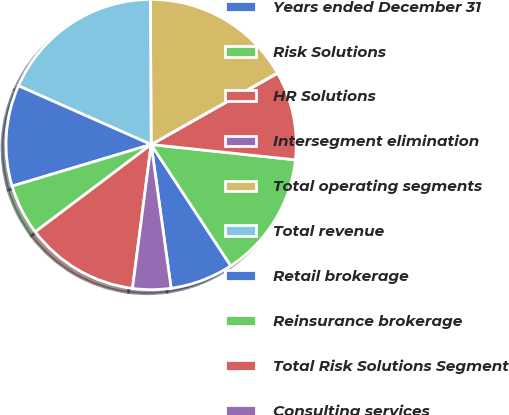<chart> <loc_0><loc_0><loc_500><loc_500><pie_chart><fcel>Years ended December 31<fcel>Risk Solutions<fcel>HR Solutions<fcel>Intersegment elimination<fcel>Total operating segments<fcel>Total revenue<fcel>Retail brokerage<fcel>Reinsurance brokerage<fcel>Total Risk Solutions Segment<fcel>Consulting services<nl><fcel>7.05%<fcel>14.07%<fcel>9.86%<fcel>0.04%<fcel>16.88%<fcel>18.28%<fcel>11.26%<fcel>5.65%<fcel>12.67%<fcel>4.25%<nl></chart> 